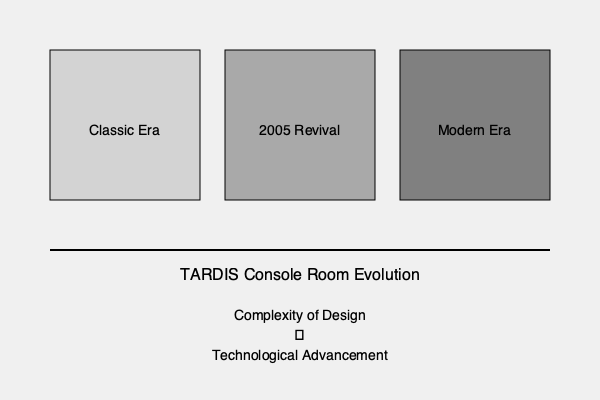Analyze the visual progression of TARDIS console room designs throughout Doctor Who history. How does the complexity of design correlate with the technological advancements shown in the series, and what might this suggest about the evolution of the show's production values? 1. Classic Era (1963-1989):
   - Simple, minimalist design
   - Often white or light-colored walls
   - Basic, analog-looking controls
   - Limited budget reflected in set design

2. 2005 Revival:
   - More complex, organic design
   - Coral-like structures
   - Mix of analog and digital elements
   - Increased budget allowing for more detailed sets

3. Modern Era (2010 onwards):
   - Highly intricate, multi-level designs
   - Advanced holographic displays
   - Complex lighting and moving parts
   - Reflects high production values and CGI capabilities

4. Correlation analysis:
   - As the show progressed, console room designs became more complex
   - Technological advancements in the show (e.g., new TARDIS functions) are mirrored in set design
   - Increased complexity reflects real-world technological progress and higher audience expectations

5. Production value implications:
   - More elaborate designs suggest higher budgets
   - Advanced visual effects capabilities allow for more dynamic console rooms
   - Evolution of design reflects the show's ability to stay relevant and appeal to modern audiences

6. Thematic considerations:
   - Changes in design philosophy reflect different showrunners' visions
   - More alien and abstract designs in recent series emphasize the TARDIS's otherworldly nature
   - Complexity of design may symbolize the Doctor's own character development and experiences
Answer: Increasing design complexity correlates with technological advancements, reflecting higher production values and the show's evolution. 